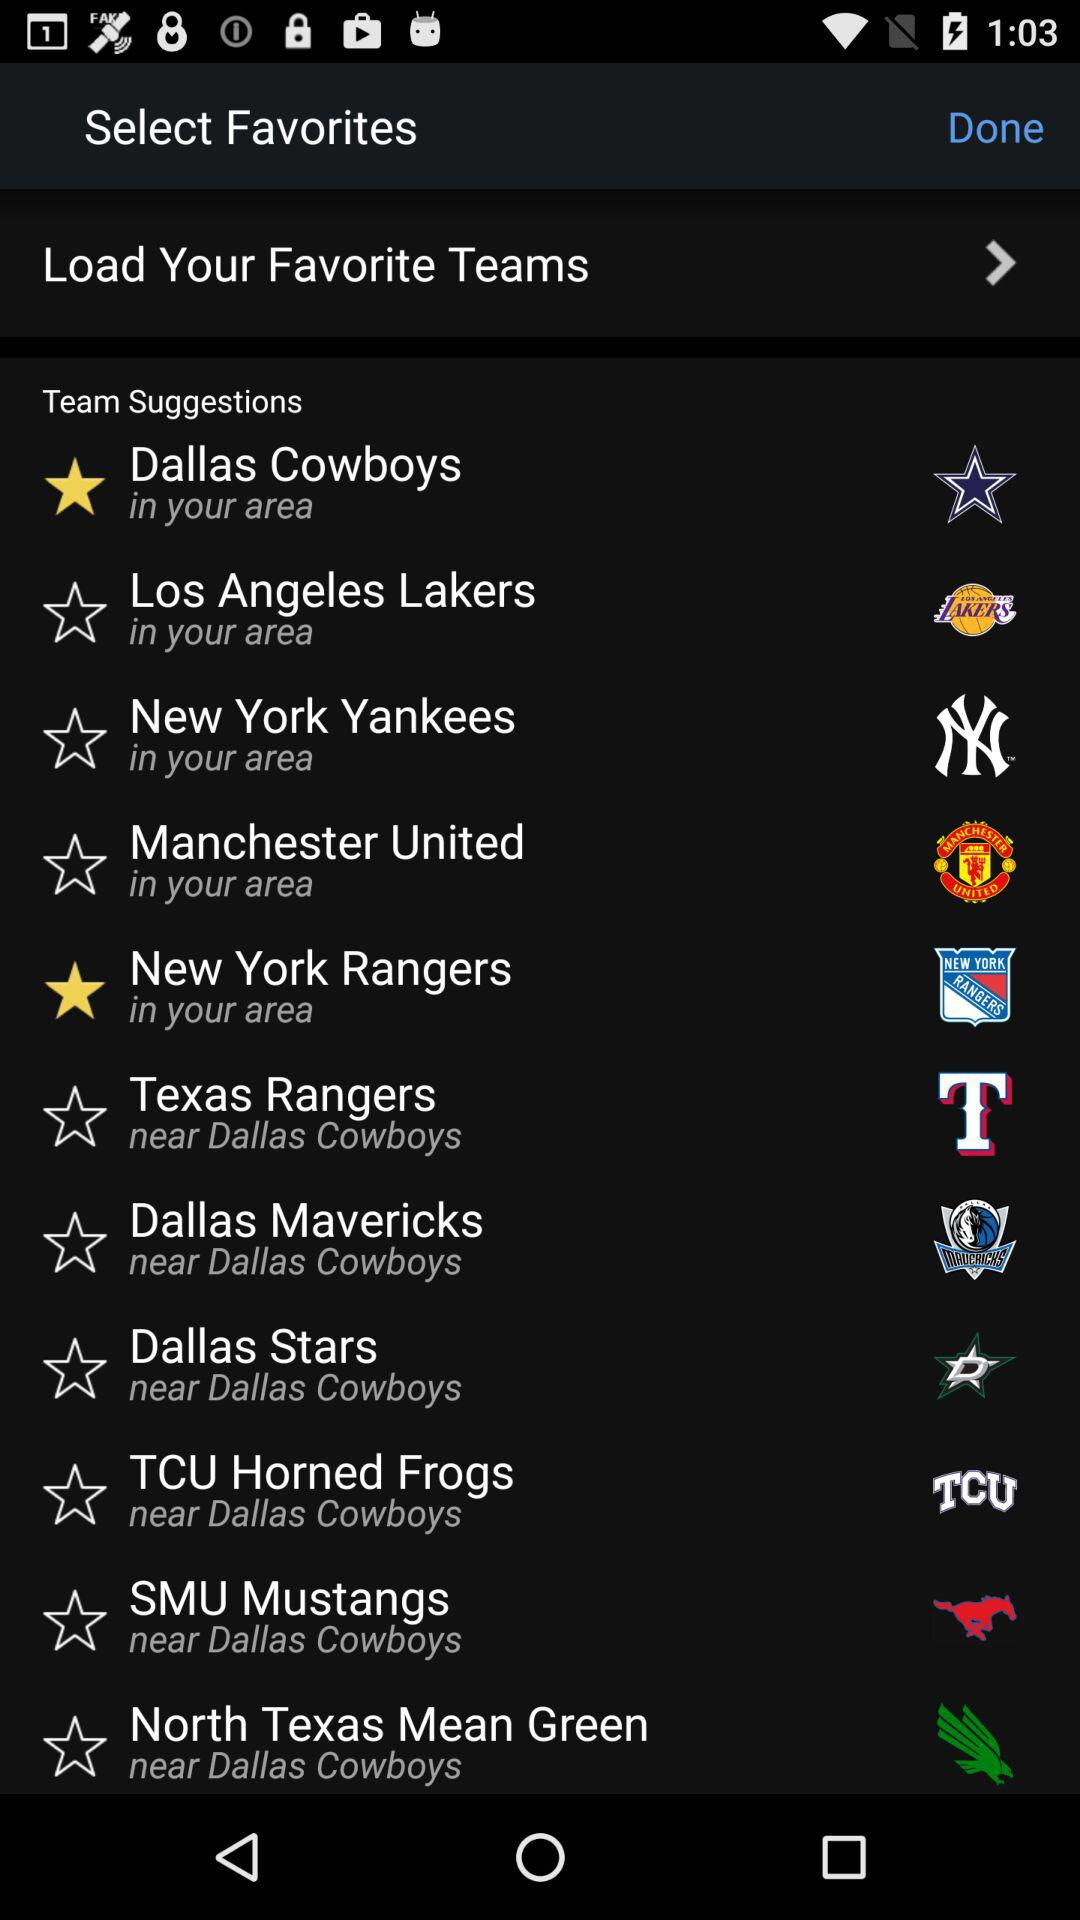Who is playing for my favorite teams?
When the provided information is insufficient, respond with <no answer>. <no answer> 